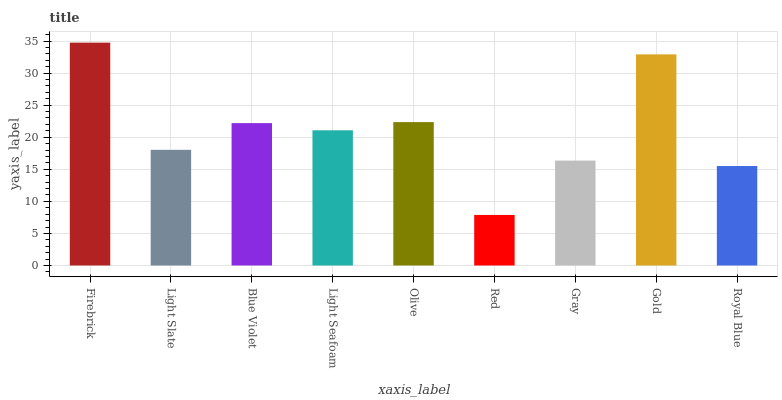Is Red the minimum?
Answer yes or no. Yes. Is Firebrick the maximum?
Answer yes or no. Yes. Is Light Slate the minimum?
Answer yes or no. No. Is Light Slate the maximum?
Answer yes or no. No. Is Firebrick greater than Light Slate?
Answer yes or no. Yes. Is Light Slate less than Firebrick?
Answer yes or no. Yes. Is Light Slate greater than Firebrick?
Answer yes or no. No. Is Firebrick less than Light Slate?
Answer yes or no. No. Is Light Seafoam the high median?
Answer yes or no. Yes. Is Light Seafoam the low median?
Answer yes or no. Yes. Is Firebrick the high median?
Answer yes or no. No. Is Royal Blue the low median?
Answer yes or no. No. 